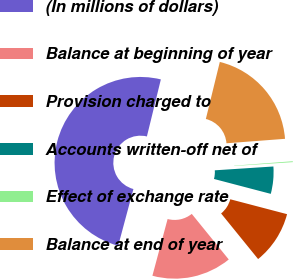Convert chart to OTSL. <chart><loc_0><loc_0><loc_500><loc_500><pie_chart><fcel>(In millions of dollars)<fcel>Balance at beginning of year<fcel>Provision charged to<fcel>Accounts written-off net of<fcel>Effect of exchange rate<fcel>Balance at end of year<nl><fcel>49.65%<fcel>15.02%<fcel>10.07%<fcel>5.12%<fcel>0.17%<fcel>19.97%<nl></chart> 